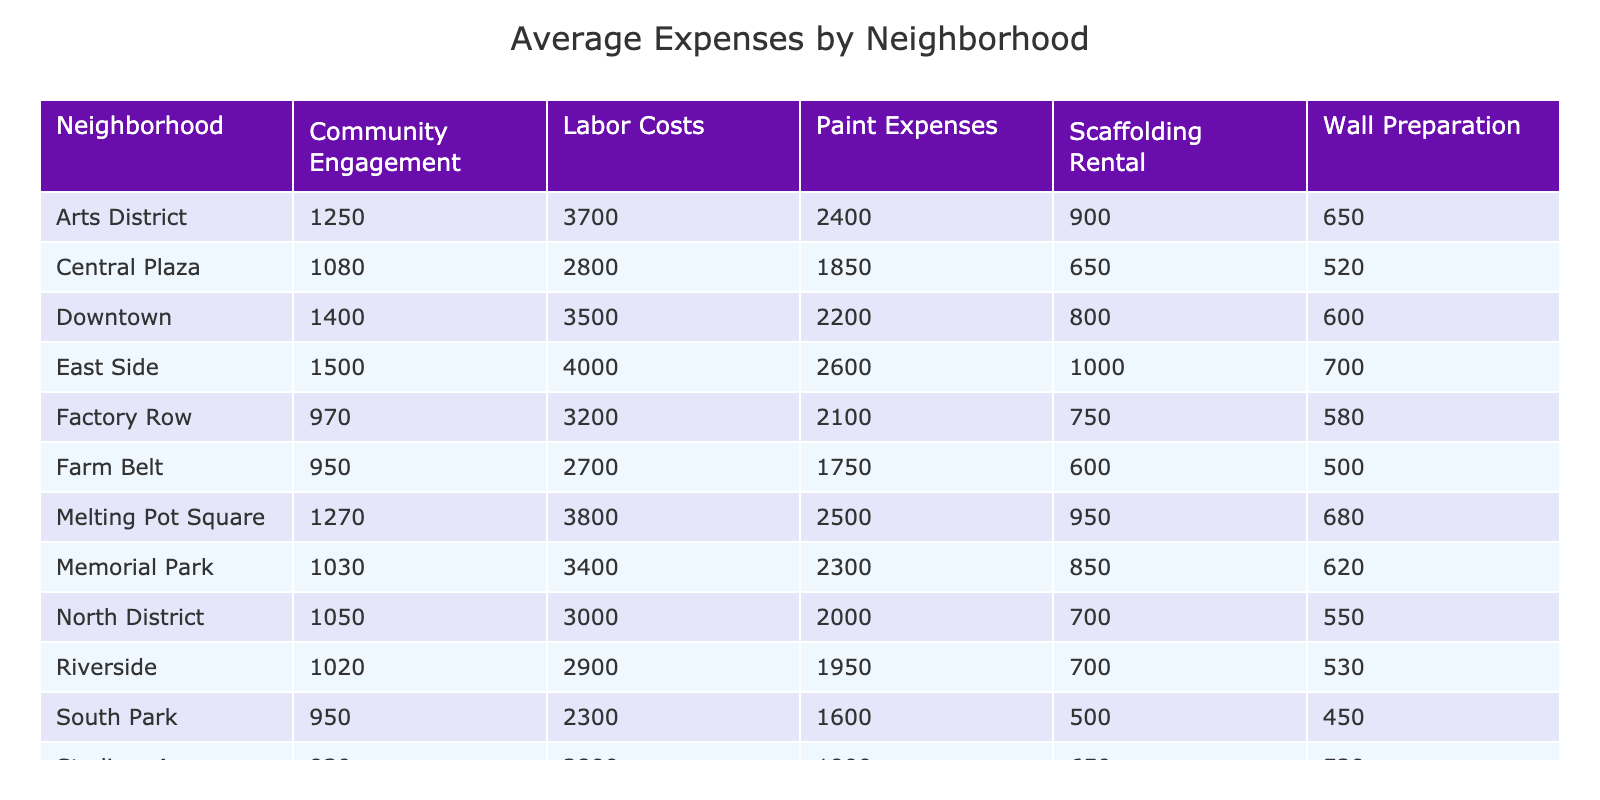What is the average paint expense in the Downtown neighborhood? From the table, we see that the Downtown neighborhood has one project, the Culkin Founders Mural, with a paint expense of 2200. Since there's only one project, the average paint expense for Downtown is simply 2200.
Answer: 2200 Which neighborhood has the highest average labor costs? Looking at the table, we can see the average labor costs for each neighborhood. Calculating these, we find North District has 3000 (Civil Rights Movement Homage) and Downtown has 3500 (Culkin Founders Mural). Comparing all, the highest average labor cost is in Downtown at 3500.
Answer: Downtown Is the average scaffolding rental cost higher in the East Side or in the West End? The East Side has the Indigenous Peoples Tribute project with a scaffolding rental of 1000. The West End has the Railroad Heritage Wall with a scaffolding rental of 600. Thus, 1000 (East Side) is greater than 600 (West End), making the average scaffolding rental higher in the East Side.
Answer: Yes What is the total average community engagement cost across all neighborhoods? From the table, we can sum all community engagement costs: 1400 (Downtown) + 800 (West End) + 1500 (East Side) + 1050 (North District) + 950 (South Park) + 1250 (Arts District) + 970 (Factory Row) + 930 (Stadium Area) + 1270 (Melting Pot Square) + 1020 (Riverside) + 950 (Farm Belt) + 1030 (Memorial Park) + 840 (Story Corner) + 900 (University District) + 1080 (Central Plaza) = 14900. Dividing by the number of neighborhoods (15), we get an average of 993.33 (rounded to two decimal places).
Answer: 993.33 Which neighborhood had the lowest average wall preparation costs? By examining the wall preparation costs for each neighborhood, we see that South Park has 450, while others have higher costs. Since it is the only instance below others, South Park thus has the lowest average wall preparation costs.
Answer: South Park 